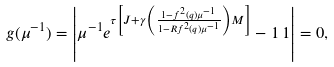<formula> <loc_0><loc_0><loc_500><loc_500>g ( \mu ^ { - 1 } ) = \left | \mu ^ { - 1 } e ^ { \tau \left [ { J } + \gamma \left ( \frac { 1 - f ^ { 2 } ( q ) \mu ^ { - 1 } } { 1 - R f ^ { 2 } ( q ) \mu ^ { - 1 } } \right ) { M } \right ] } - 1 \, 1 \right | = 0 ,</formula> 